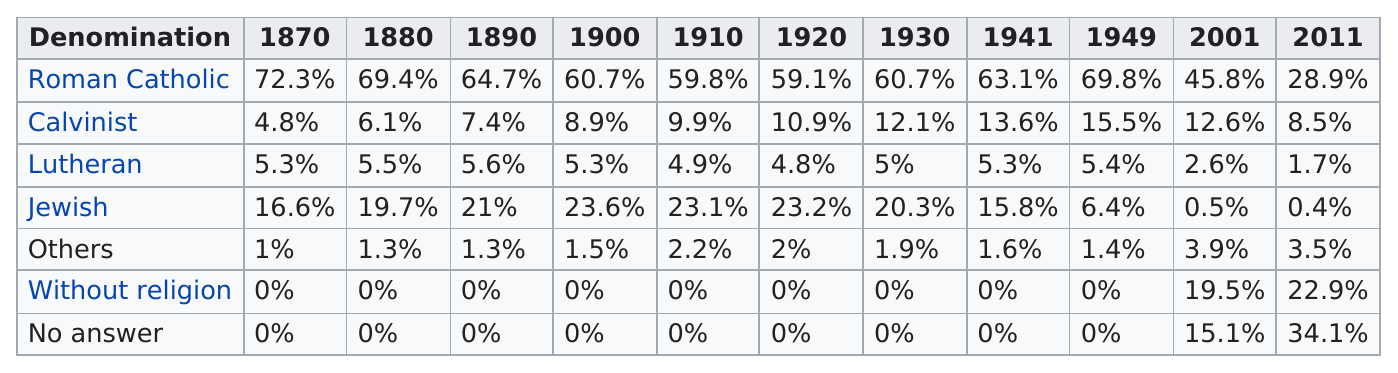Highlight a few significant elements in this photo. In 1880, the Roman Catholic denomination held the largest percentage of the population among all other denominations. In 2011, the percentage of those without religion was at least 20%. In 2011, 43% of people identified as religious. The largest religious denomination in Budapest is Roman Catholic. After 1949, the denomination that saw the largest percentage increase in its adherents was the "Without Religion" category. 